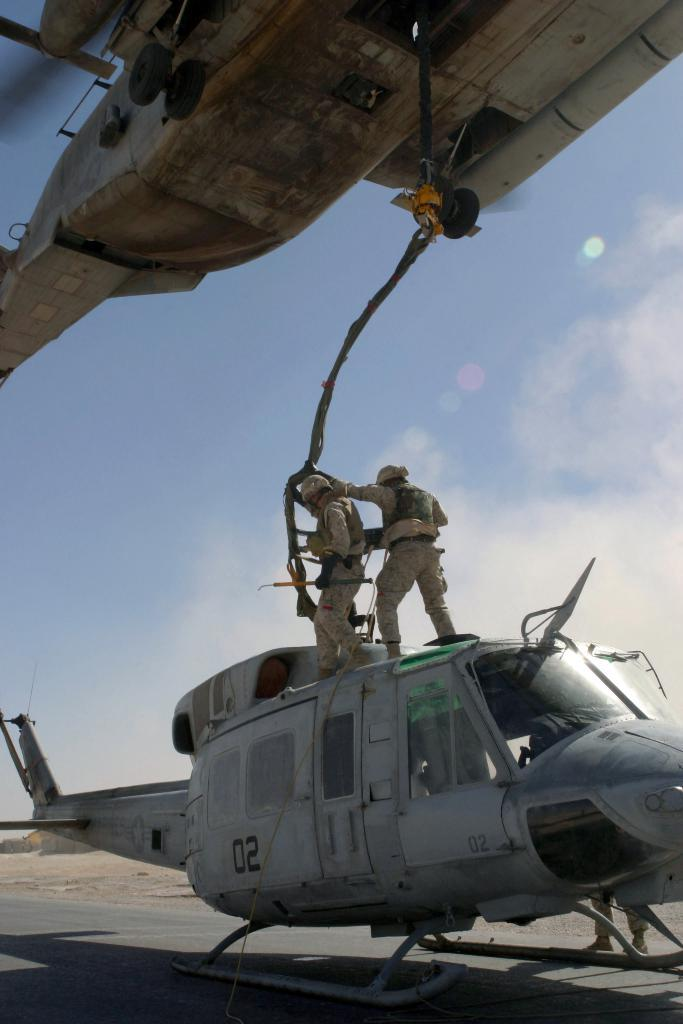Provide a one-sentence caption for the provided image. Soldiers are connecting a cable from a hovering helicopter to a grounded helicopter marked 02. 